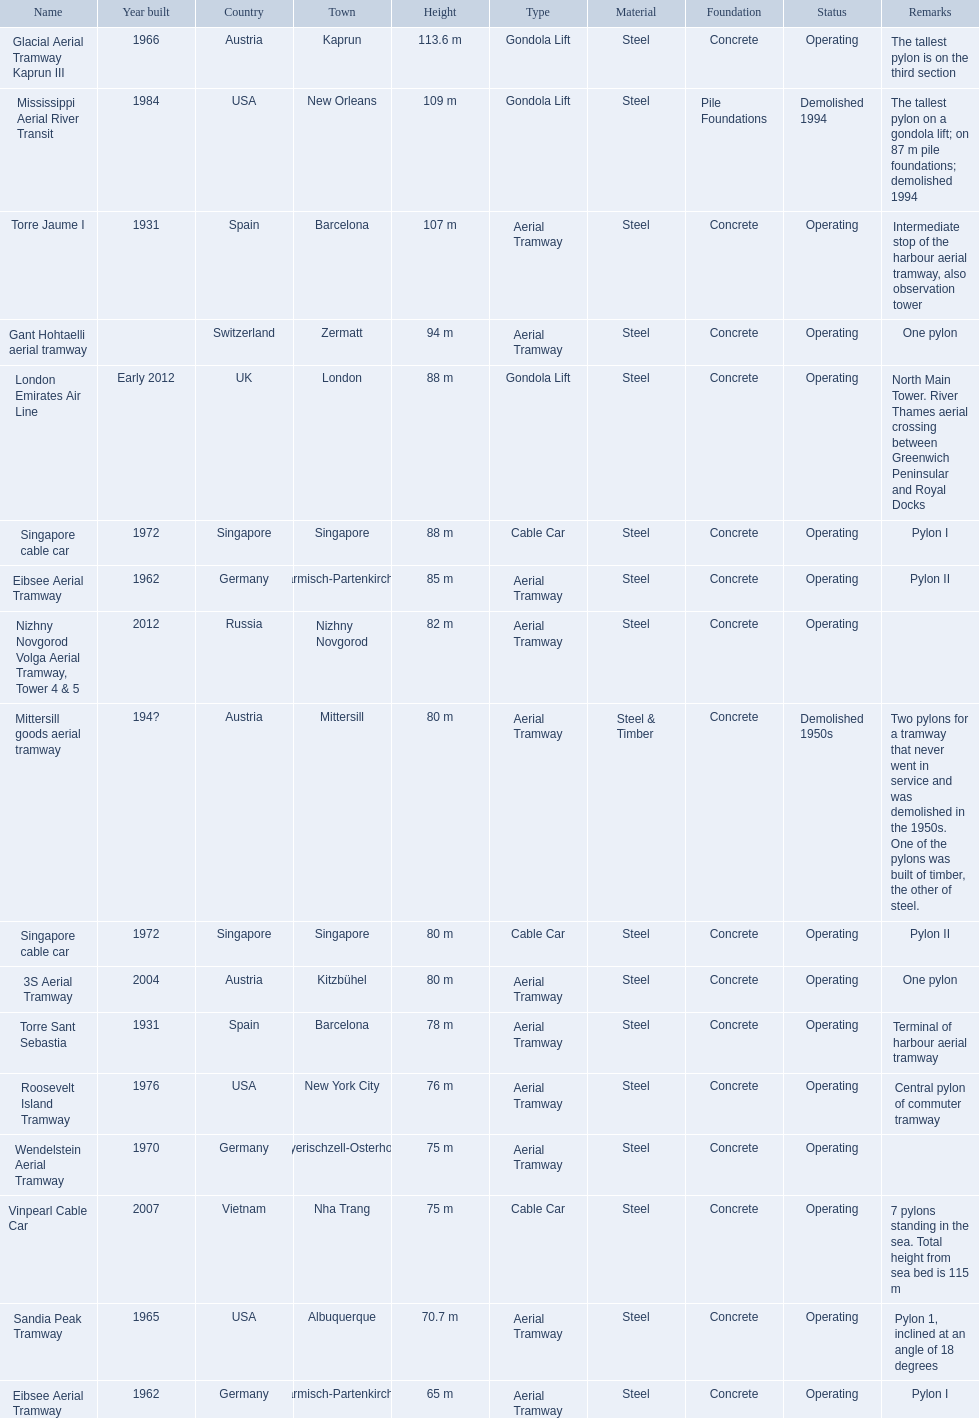Which aerial lifts are over 100 meters tall? Glacial Aerial Tramway Kaprun III, Mississippi Aerial River Transit, Torre Jaume I. Which of those was built last? Mississippi Aerial River Transit. And what is its total height? 109 m. 